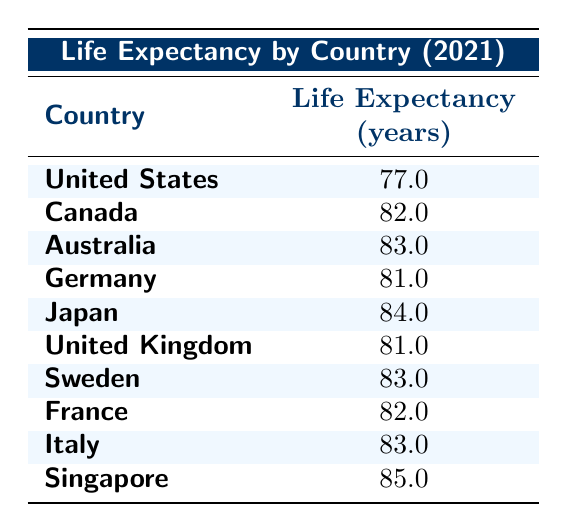What is the life expectancy of Japan? From the table, I can see that Japan has a life expectancy listed at 84.0 years.
Answer: 84.0 Which country has the lowest life expectancy? Observing the table, the United States has the lowest life expectancy at 77.0 years compared to other listed countries.
Answer: United States What is the average life expectancy of the countries in the table? To find the average, I will sum all the life expectancies: (77.0 + 82.0 + 83.0 + 81.0 + 84.0 + 81.0 + 83.0 + 82.0 + 83.0 + 85.0) = 828.0. There are 10 countries, so the average is 828.0 / 10 = 82.8.
Answer: 82.8 Is it true that Canada has a higher life expectancy than Germany? Comparing the values in the table, Canada has a life expectancy of 82.0 years, while Germany has 81.0 years; therefore, it is true that Canada has a higher life expectancy.
Answer: Yes What is the difference in life expectancy between Singapore and Italy? From the table, Singapore's life expectancy is 85.0 years, and Italy's is 83.0 years. The difference is 85.0 - 83.0 = 2.0 years.
Answer: 2.0 Which countries have a life expectancy greater than 82 years? I can scan the table for countries with life expectancies over 82 years: Canada (82.0), Australia (83.0), Japan (84.0), Singapore (85.0) all surpass this threshold.
Answer: Canada, Australia, Japan, Singapore What percentage of the total healthcare spending per capita does the United States account for? The total healthcare spending per capita across the table is 12000 + 6500 + 5500 + 7000 + 4000 + 4300 + 5000 + 5800 + 4000 + 10000 = 52200. The percentage is (12000 / 52200) * 100 = approximately 22.97%.
Answer: 22.97% Are there any countries with a life expectancy of 83 years? Looking at the table, both Australia and Italy have a life expectancy of 83.0 years, confirming that there are countries with this specific life expectancy.
Answer: Yes What is the combined life expectancy of the United Kingdom and Sweden? The life expectancy of the United Kingdom is 81.0 years and Sweden is 83.0 years; thus, the combined life expectancy is 81.0 + 83.0 = 164.0 years.
Answer: 164.0 